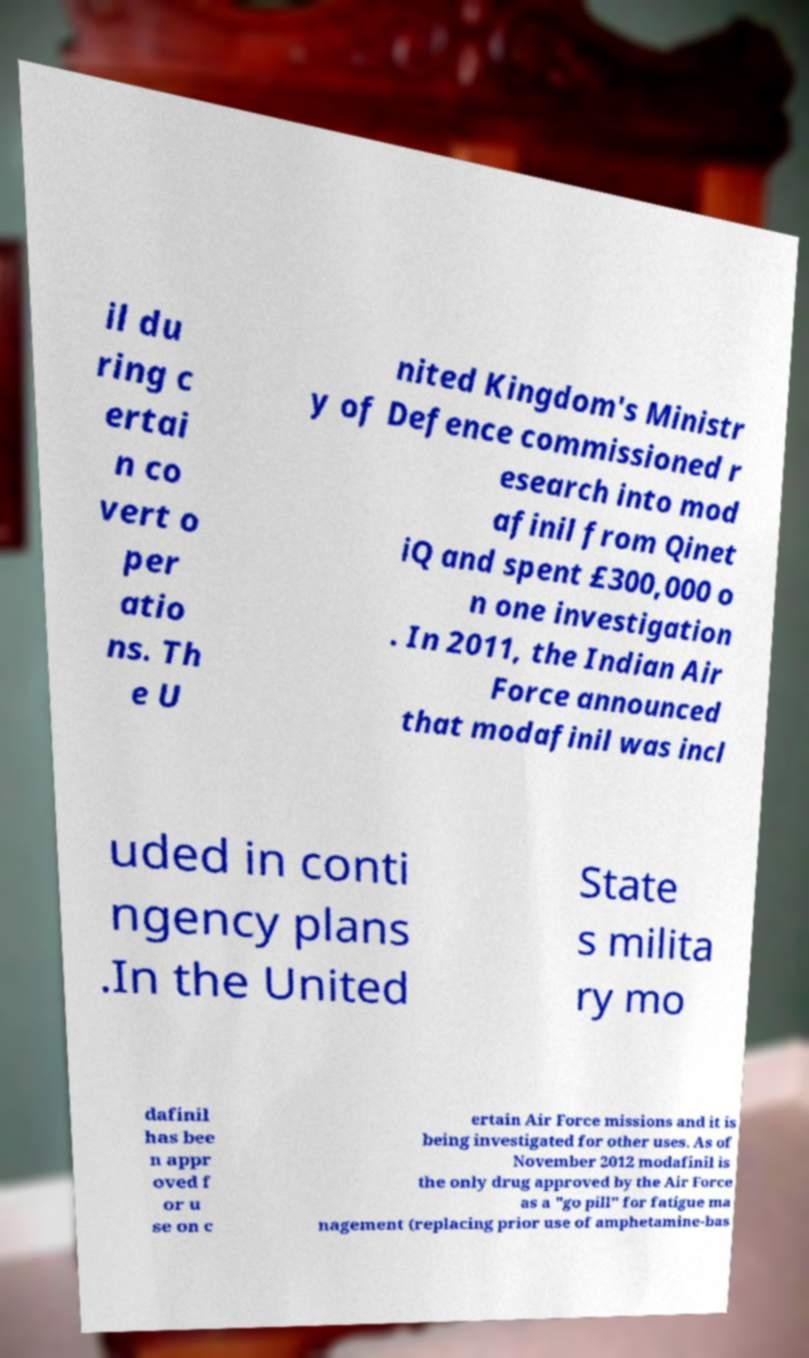Please identify and transcribe the text found in this image. il du ring c ertai n co vert o per atio ns. Th e U nited Kingdom's Ministr y of Defence commissioned r esearch into mod afinil from Qinet iQ and spent £300,000 o n one investigation . In 2011, the Indian Air Force announced that modafinil was incl uded in conti ngency plans .In the United State s milita ry mo dafinil has bee n appr oved f or u se on c ertain Air Force missions and it is being investigated for other uses. As of November 2012 modafinil is the only drug approved by the Air Force as a "go pill" for fatigue ma nagement (replacing prior use of amphetamine-bas 